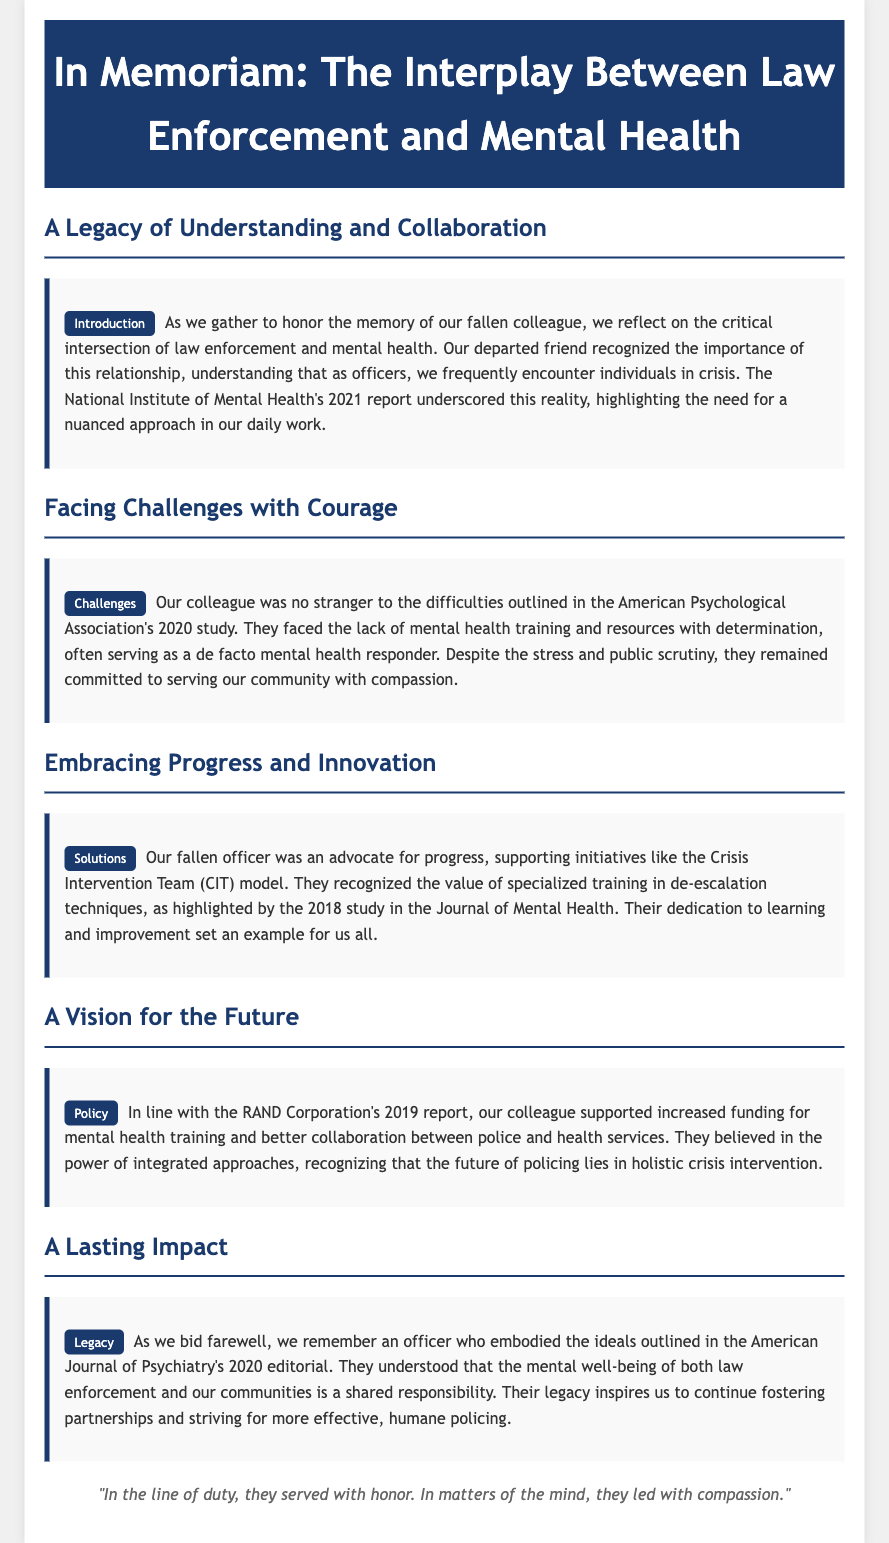What is the title of the document? The title is stated in the header of the document.
Answer: In Memoriam: The Interplay Between Law Enforcement and Mental Health Who conducted the 2021 report highlighting the need for a nuanced approach in law enforcement? The document attributes this report to a specific organization, mentioned in the introduction.
Answer: National Institute of Mental Health What initiative did the fallen officer support for crisis intervention? The document specifically mentions the name of the model that the officer advocated for.
Answer: Crisis Intervention Team (CIT) What year did the American Psychological Association release a study on the challenges faced by officers? The challenge section of the document provides the publication year of the study.
Answer: 2020 According to the RAND Corporation's report, what did the officer support regarding mental health training? The policy section discusses a recommendation related to mental health training funding.
Answer: Increased funding for mental health training What is one key idea the officer believed regarding the mental well-being of law enforcement and communities? The legacy section summarizes a core belief of the officer as stated in the document.
Answer: Shared responsibility What type of officer was the individual being honored? The introduction references the role of the individual in law enforcement.
Answer: Officer What was the date of the editorial published in the American Journal of Psychiatry? The legacy section mentions the publication year of this editorial.
Answer: 2020 